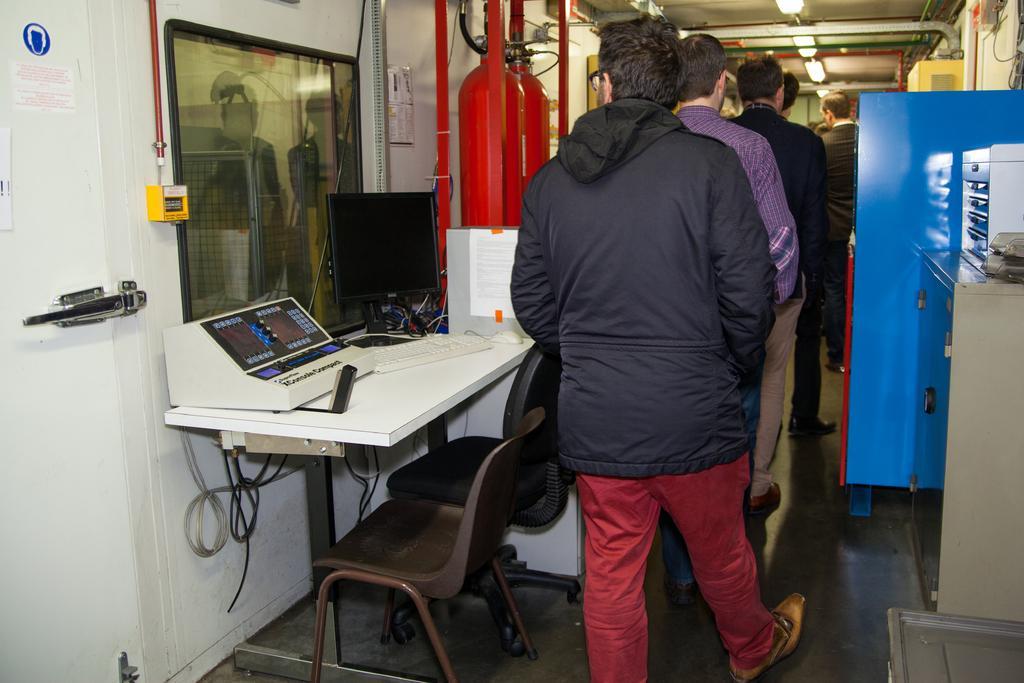How would you summarize this image in a sentence or two? In this picture there are few people standing in a row. To the left side there is a door and a table with monitor, keyboard and one instrument on it. There are two chairs. We can also see red color cylinder on the top. There are lights on the top corner. And to the right side there is a cupboard and blue color fridge. 